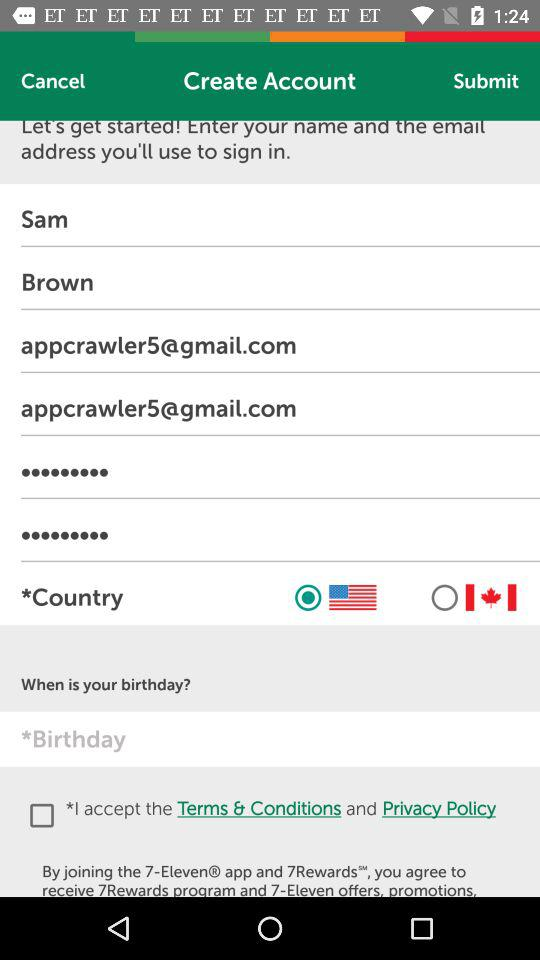What is the name of the application? The names of the applications are "7-Eleven" and "7Rewards". 